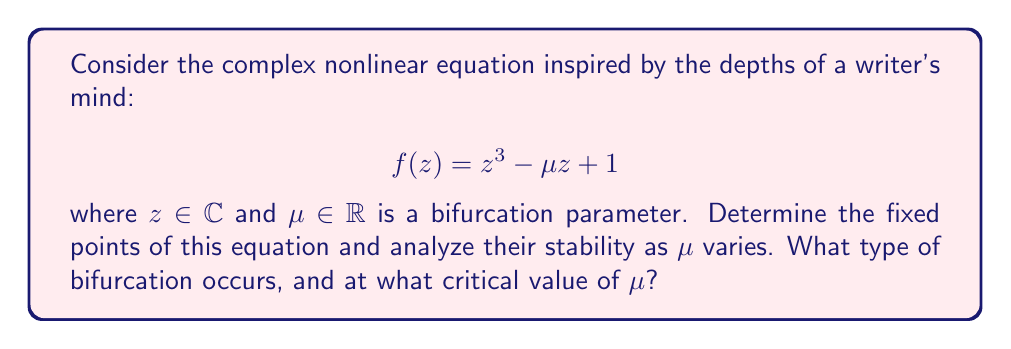Give your solution to this math problem. 1. Fixed points:
   To find the fixed points, we solve $f(z) = z$:
   $$z^3 - \mu z + 1 = z$$
   $$z^3 - (\mu + 1)z + 1 = 0$$

2. Bifurcation analysis:
   This is a cubic equation. Let's substitute $w = z - \frac{1}{3}$ to eliminate the quadratic term:
   $$w^3 + pw + q = 0$$
   where $p = -(\mu + 1) - \frac{1}{3}$ and $q = \frac{2}{27} - \frac{\mu + 1}{3}$

3. Discriminant:
   The discriminant is given by $\Delta = (\frac{q}{2})^2 + (\frac{p}{3})^3$
   Bifurcation occurs when $\Delta = 0$, which gives:
   $$(\frac{2}{27} - \frac{\mu + 1}{3})^2 + (-\frac{\mu + 1}{3} - \frac{1}{9})^3 = 0$$

4. Solving for critical $\mu$:
   This equation simplifies to:
   $$\mu^3 + \frac{3}{2}\mu^2 - \frac{3}{2}\mu - 1 = 0$$
   The real solution to this equation is $\mu_c = \frac{1}{\sqrt{3}}$

5. Type of bifurcation:
   At $\mu = \mu_c$, two complex conjugate fixed points collide with a real fixed point. This is characteristic of a pitchfork bifurcation.

6. Stability analysis:
   The derivative of $f(z)$ is $f'(z) = 3z^2 - \mu$
   - For $\mu < \mu_c$: One stable real fixed point and two unstable complex fixed points
   - For $\mu = \mu_c$: One non-hyperbolic fixed point (bifurcation point)
   - For $\mu > \mu_c$: Three real fixed points (two stable, one unstable)
Answer: Pitchfork bifurcation at $\mu_c = \frac{1}{\sqrt{3}}$ 